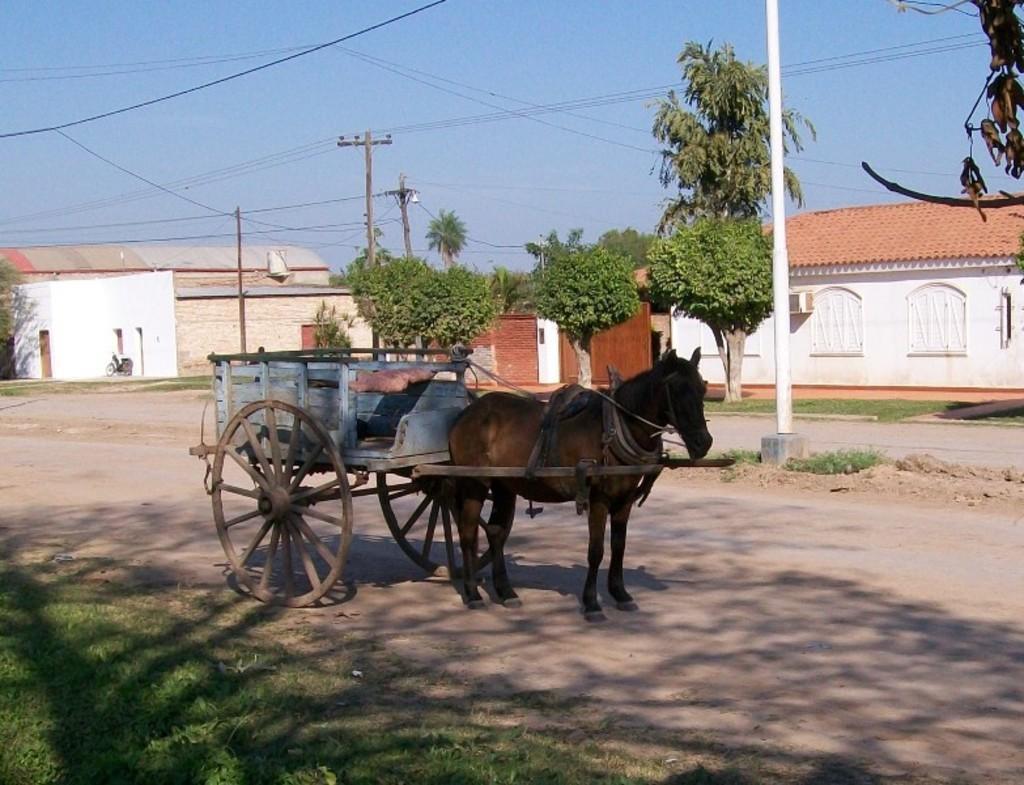Could you give a brief overview of what you see in this image? In this image in the center there is one vehicle and horse, at the bottom there is a walkway and some grass. In the background there are some houses, trees and wires. On the top of the image there is sky. 